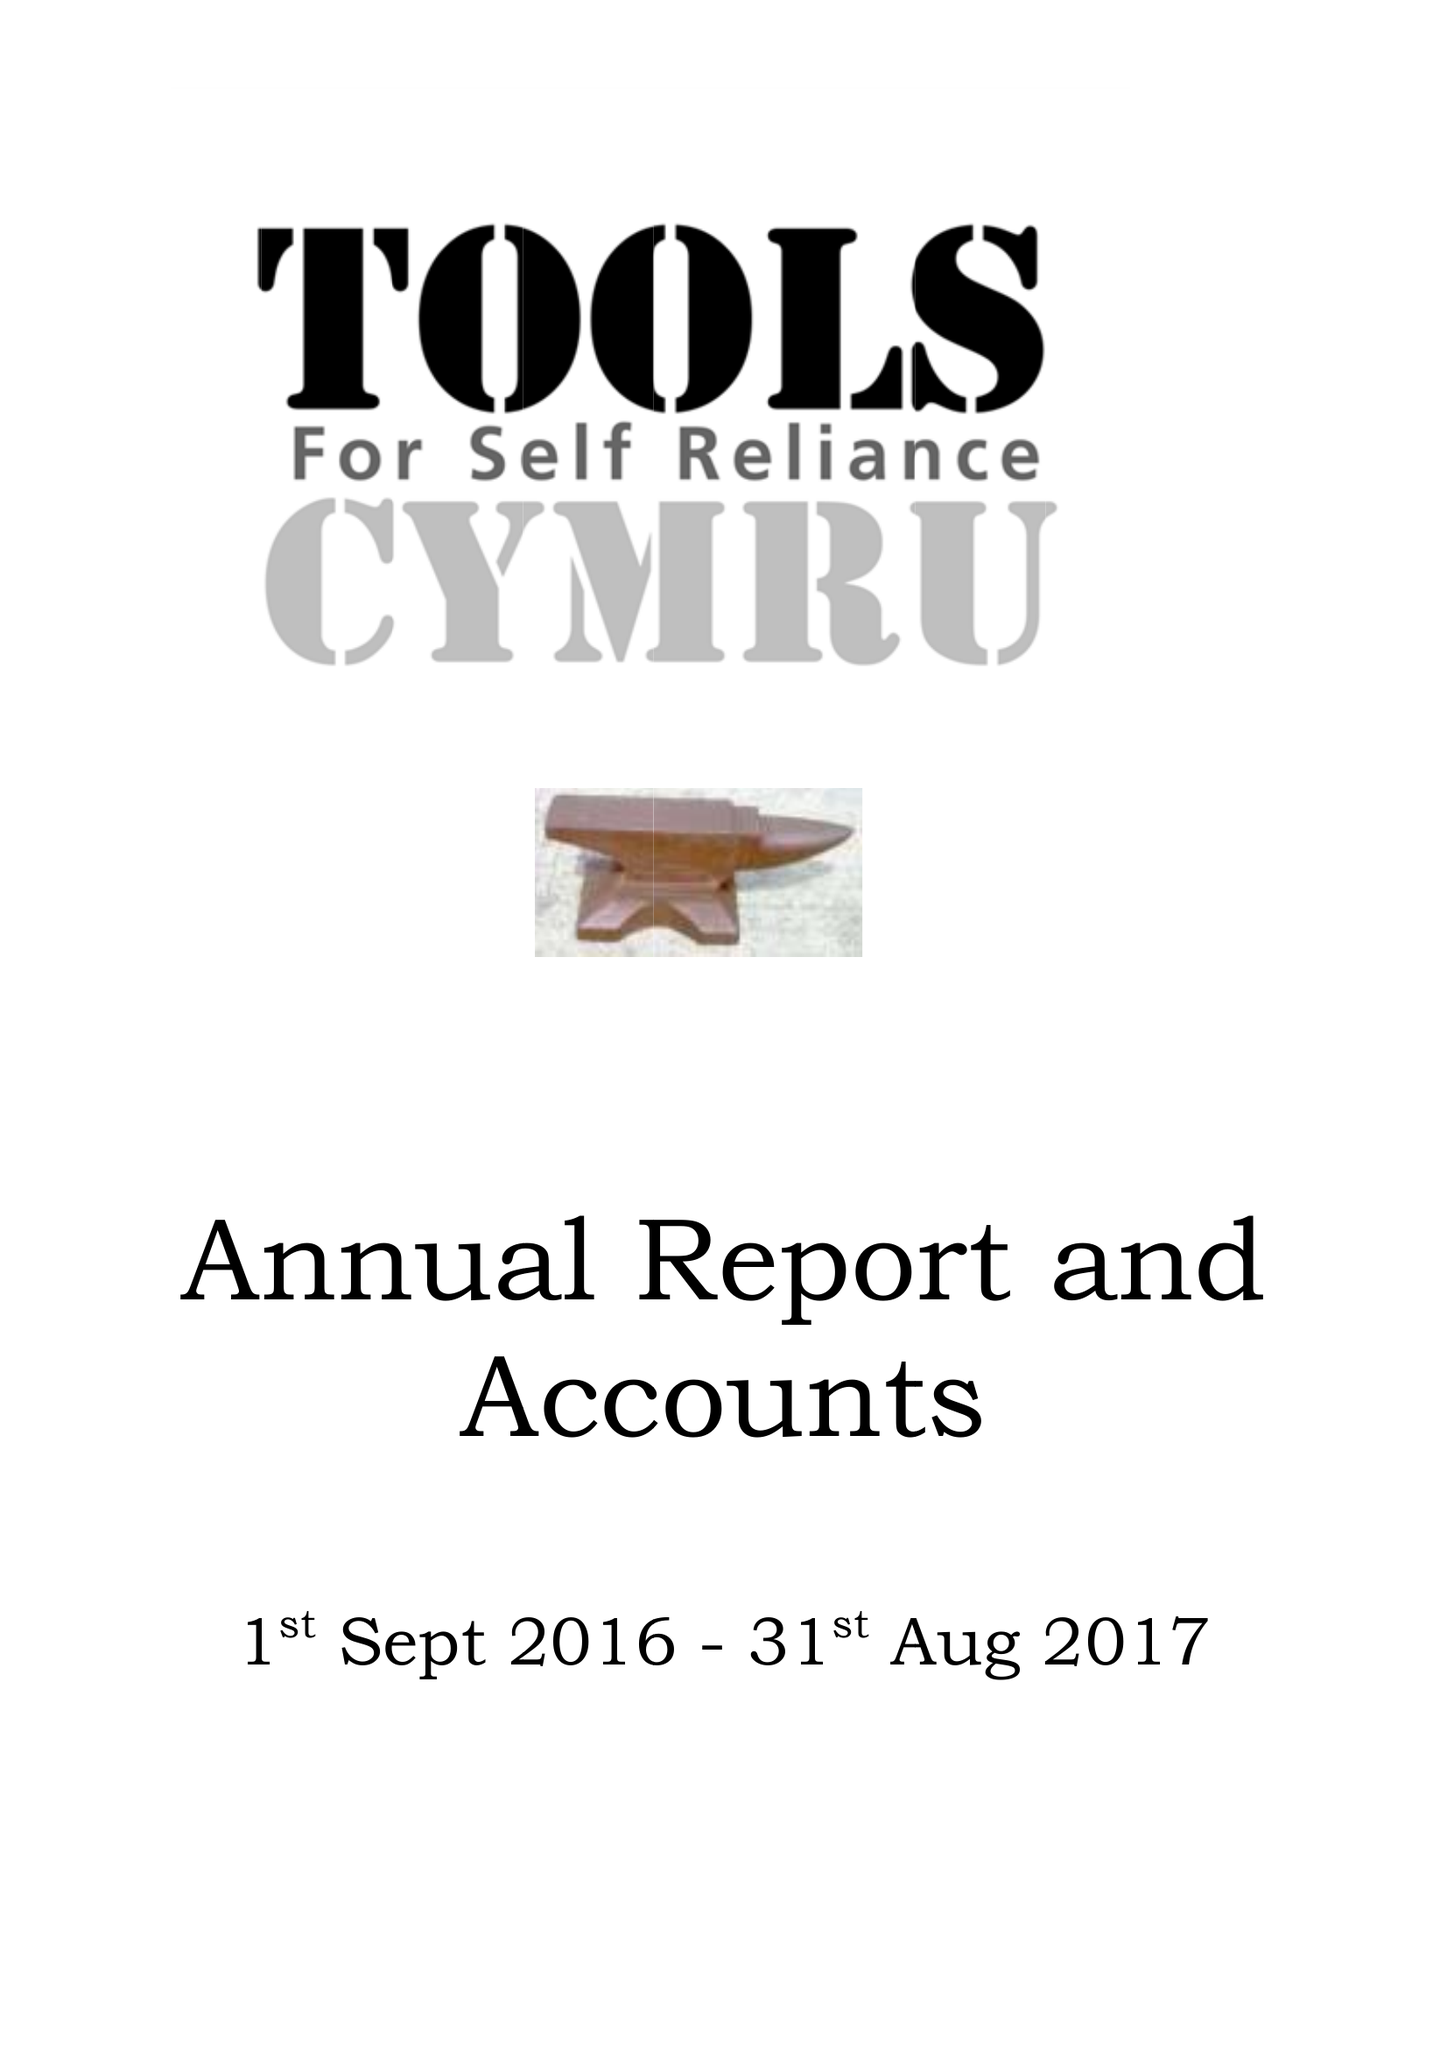What is the value for the address__postcode?
Answer the question using a single word or phrase. NP8 1BZ 